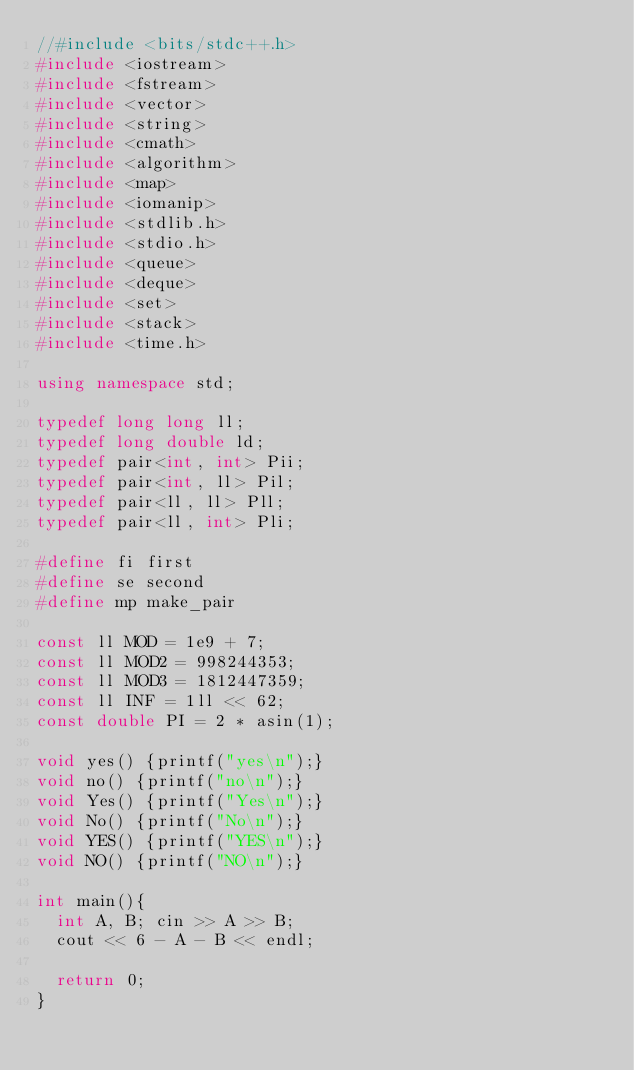Convert code to text. <code><loc_0><loc_0><loc_500><loc_500><_C++_>//#include <bits/stdc++.h>
#include <iostream>
#include <fstream>
#include <vector>
#include <string>
#include <cmath>
#include <algorithm>
#include <map>
#include <iomanip>
#include <stdlib.h>
#include <stdio.h>
#include <queue>
#include <deque>
#include <set>
#include <stack>
#include <time.h>
 
using namespace std;
 
typedef long long ll;
typedef long double ld;
typedef pair<int, int> Pii;
typedef pair<int, ll> Pil;
typedef pair<ll, ll> Pll;
typedef pair<ll, int> Pli;

#define fi first
#define se second
#define mp make_pair
 
const ll MOD = 1e9 + 7;
const ll MOD2 = 998244353;
const ll MOD3 = 1812447359;
const ll INF = 1ll << 62;
const double PI = 2 * asin(1);

void yes() {printf("yes\n");}
void no() {printf("no\n");}
void Yes() {printf("Yes\n");}
void No() {printf("No\n");}
void YES() {printf("YES\n");}
void NO() {printf("NO\n");}

int main(){
  int A, B; cin >> A >> B;
  cout << 6 - A - B << endl;

  return 0;
}
</code> 